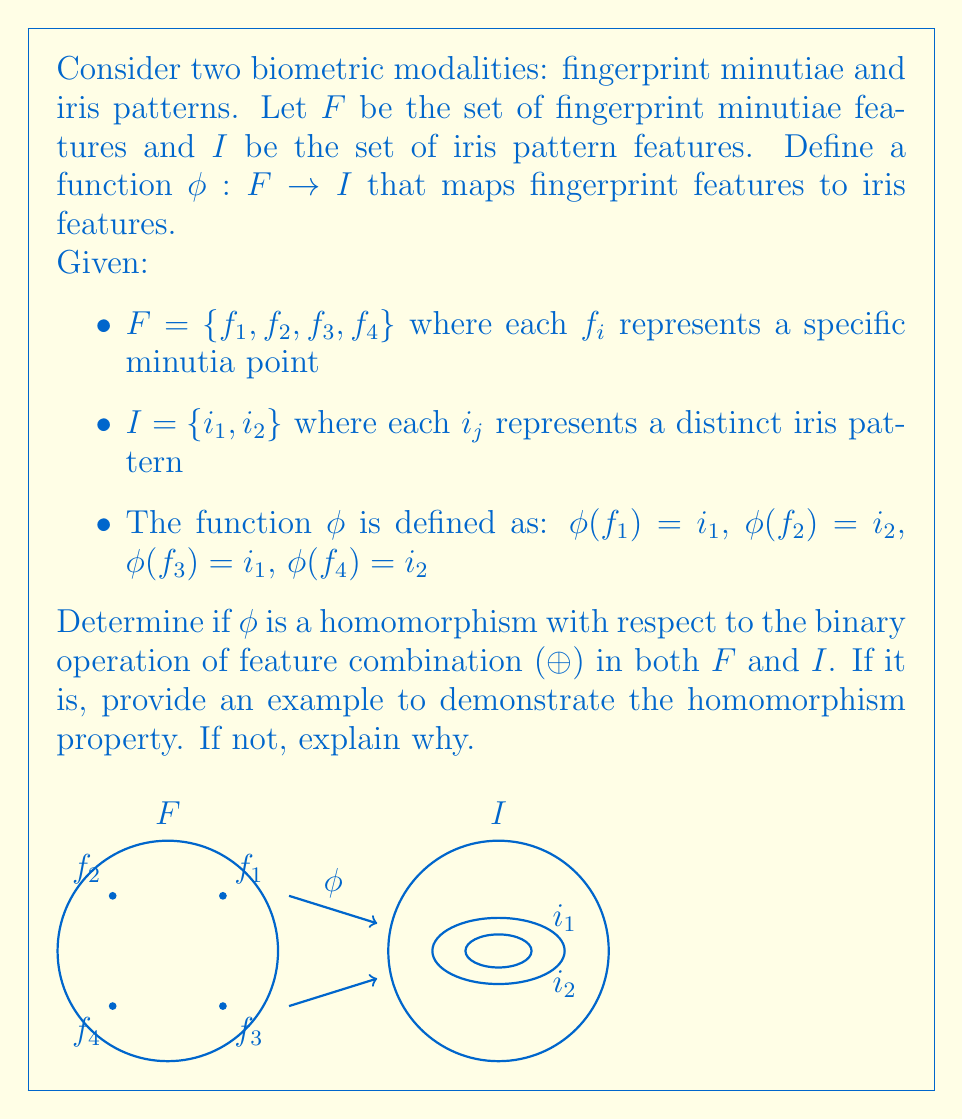Give your solution to this math problem. To determine if $\phi$ is a homomorphism, we need to check if it preserves the binary operation of feature combination (⊕) between the two sets. For $\phi$ to be a homomorphism, it must satisfy the following property for all $a, b \in F$:

$$\phi(a \oplus b) = \phi(a) \oplus \phi(b)$$

Let's analyze this step-by-step:

1) First, we need to understand how the feature combination operation (⊕) works in both sets. In biometrics, this often represents a fusion of features. For simplicity, let's assume that combining features results in selecting the dominant feature (e.g., the one with the lower index).

2) In set $F$: $f_i \oplus f_j = f_{\min(i,j)}$
   In set $I$: $i_i \oplus i_j = i_{\min(i,j)}$

3) Now, let's check the homomorphism property for a few combinations:

   a) For $f_1 \oplus f_2$:
      $\phi(f_1 \oplus f_2) = \phi(f_1) = i_1$
      $\phi(f_1) \oplus \phi(f_2) = i_1 \oplus i_2 = i_1$
      This satisfies the homomorphism property.

   b) For $f_2 \oplus f_3$:
      $\phi(f_2 \oplus f_3) = \phi(f_2) = i_2$
      $\phi(f_2) \oplus \phi(f_3) = i_2 \oplus i_1 = i_1$
      This does not satisfy the homomorphism property.

4) Since we found a counterexample in step 3b, we can conclude that $\phi$ is not a homomorphism.

5) The reason $\phi$ is not a homomorphism is that it doesn't preserve the structure of the feature combination operation between the two sets. This is because the mapping from $F$ to $I$ is many-to-one, which causes a loss of information and breaks the homomorphism property.
Answer: $\phi$ is not a homomorphism because $\phi(f_2 \oplus f_3) \neq \phi(f_2) \oplus \phi(f_3)$. 